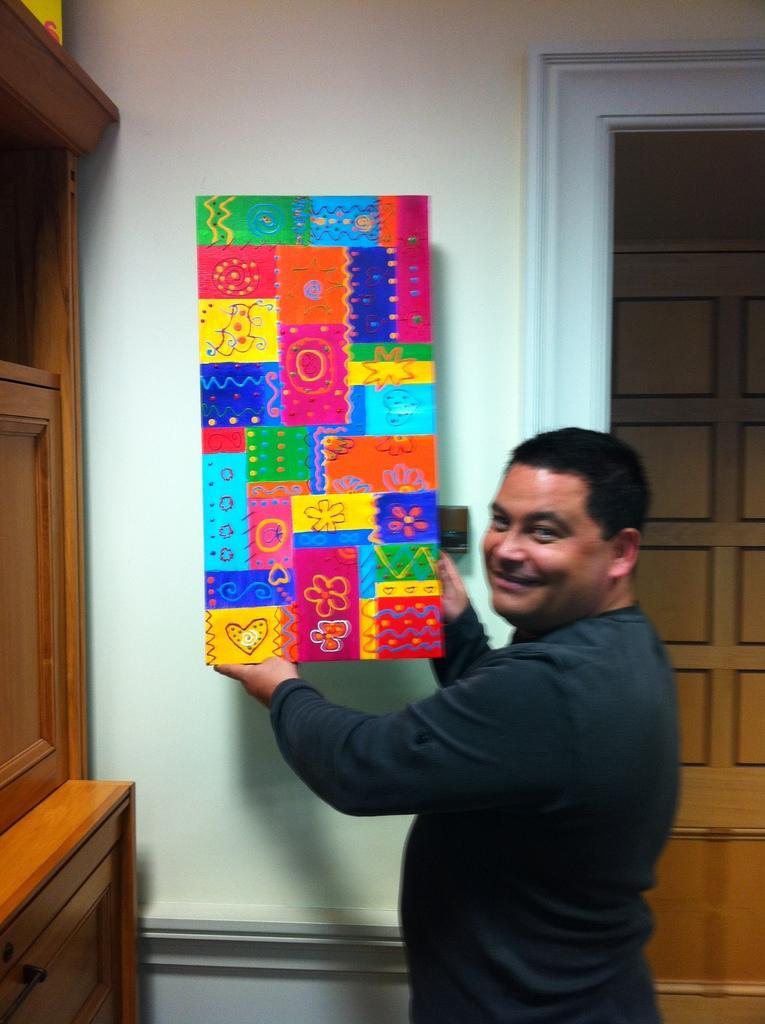Can you describe this image briefly? In this image we can see a man holding an object and standing and smiling. On the left we can see the cupboard. In the background we can see the wall and also the door. 